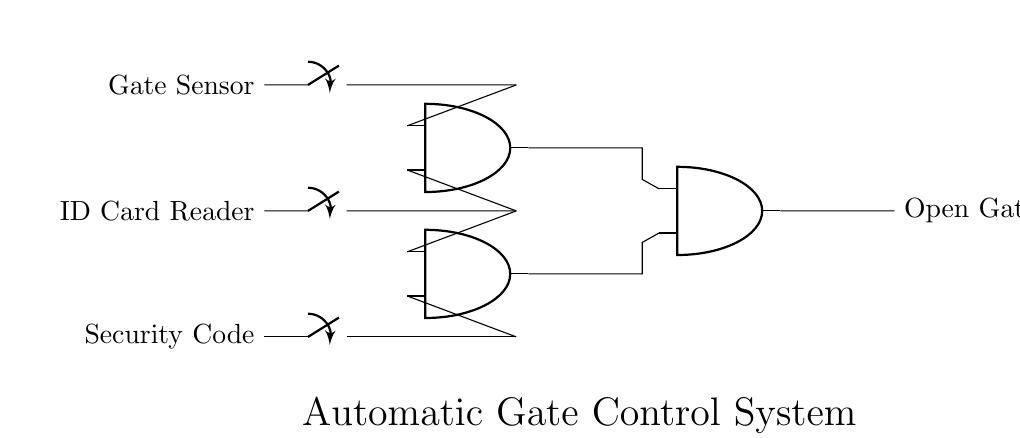What are the input components of this circuit? The input components are the Gate Sensor, ID Card Reader, and Security Code. These components send signals to the AND gates for processing before allowing the gate to open.
Answer: Gate Sensor, ID Card Reader, Security Code How many AND gates are used in this circuit? There are three AND gates in the circuit as indicated by their symbols. They are responsible for processing the signals from the input components.
Answer: Three What needs to be activated to open the gate? All three signals from the input components must be active for the final AND gate to output a signal that opens the gate, demonstrating the requirement for all conditions to be met.
Answer: All signals (Gate Sensor, ID Card Reader, Security Code) What is the output of the last AND gate? The output of the last AND gate is the signal that activates the Open Gate function. It is based on the conditions set by the previous AND gates.
Answer: Open Gate Which inputs are connected to the first AND gate? The first AND gate is connected to the Gate Sensor and the ID Card Reader inputs, meaning both must be active to contribute to the output of this AND gate.
Answer: Gate Sensor, ID Card Reader How many inputs does each AND gate have? Each AND gate has two inputs, as indicated by their standard configuration in digital logic circuits. This allows them to only output a true signal when both inputs are true.
Answer: Two 